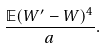Convert formula to latex. <formula><loc_0><loc_0><loc_500><loc_500>\frac { \mathbb { E } ( W ^ { \prime } - W ) ^ { 4 } } { a } .</formula> 